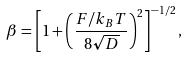Convert formula to latex. <formula><loc_0><loc_0><loc_500><loc_500>\beta = \left [ 1 + \left ( \frac { F / k _ { B } T } { 8 \sqrt { D } } \right ) ^ { 2 } \right ] ^ { - 1 / 2 } ,</formula> 